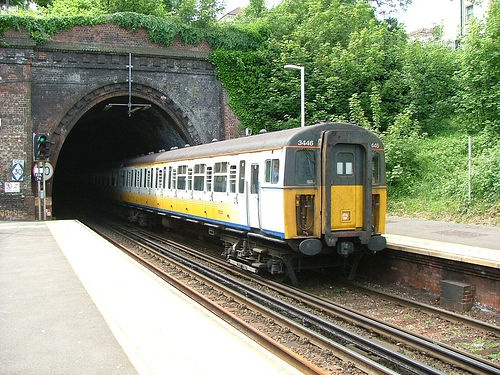Describe the objects in this image and their specific colors. I can see train in black, gray, white, and darkgray tones and traffic light in black and purple tones in this image. 